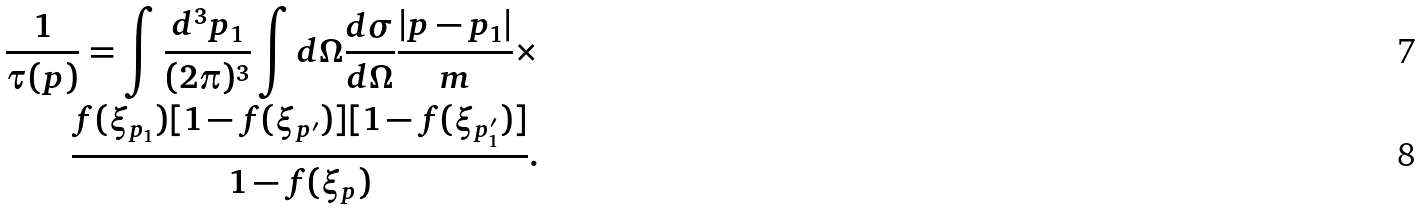<formula> <loc_0><loc_0><loc_500><loc_500>\frac { 1 } { \tau ( p ) } = \int \frac { d ^ { 3 } p _ { 1 } } { ( 2 \pi ) ^ { 3 } } \int d \Omega \frac { d \sigma } { d \Omega } \frac { | { p } - { p } _ { 1 } | } { m } \times \\ \frac { f ( \xi _ { p _ { 1 } } ) [ 1 - f ( \xi _ { p ^ { \prime } } ) ] [ 1 - f ( \xi _ { p _ { 1 } ^ { \prime } } ) ] } { 1 - f ( \xi _ { p } ) } .</formula> 